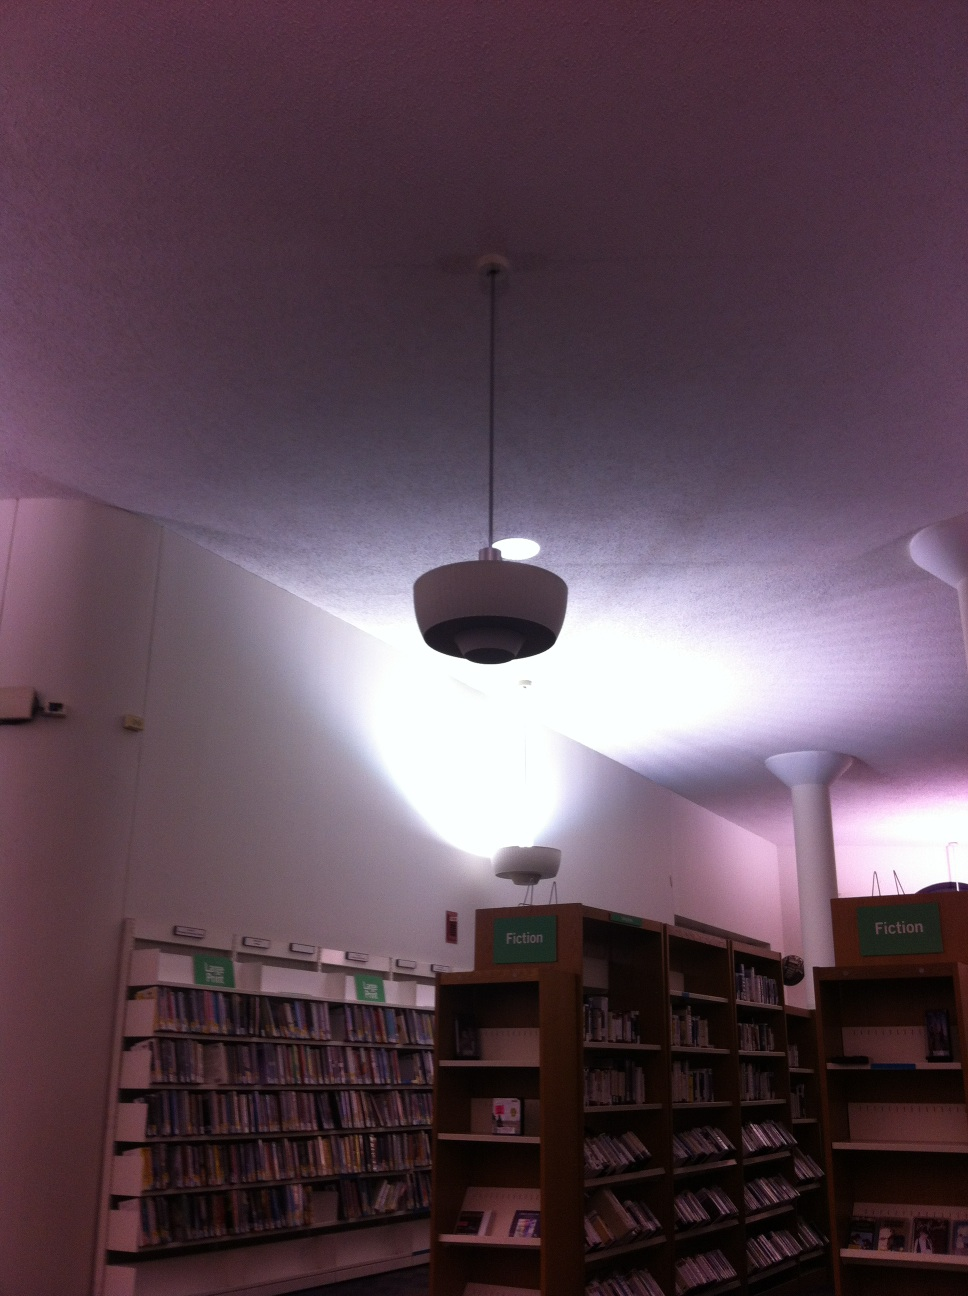Is this library well-lit? Yes, the library is well-lit, providing a comfortable environment for reading. The lighting is designed to minimize glare on book pages, making it easier for you to enjoy your reading experience without straining your eyes. 